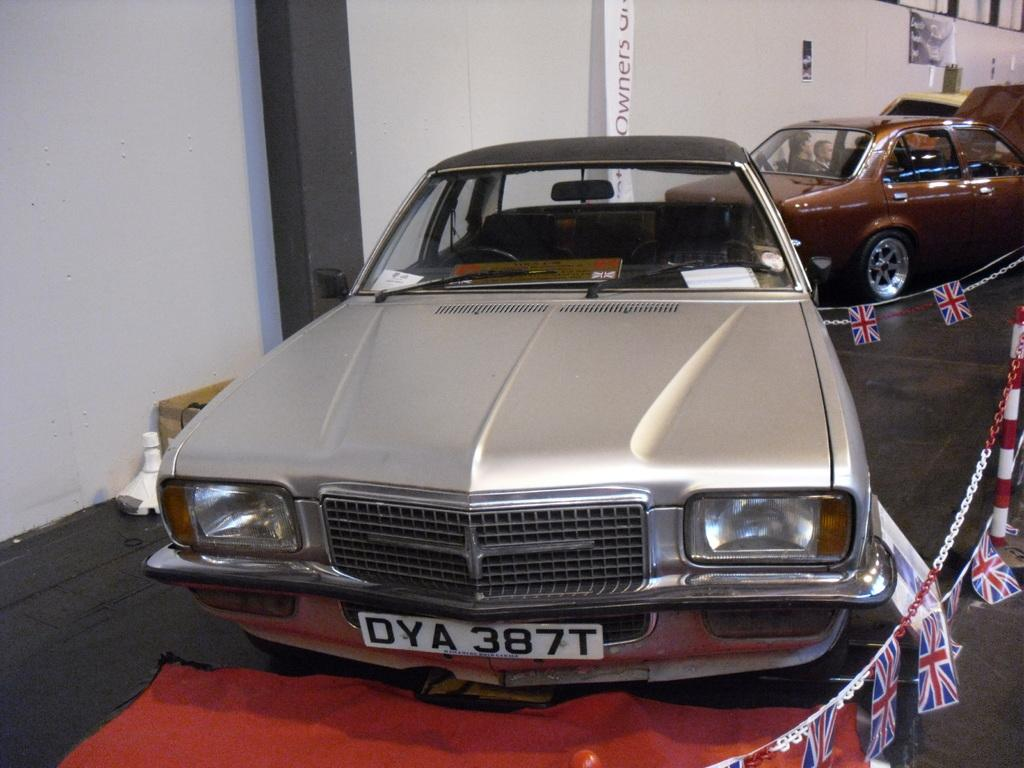What type of vehicles are present in the image? There are cars in the image. Can you describe the appearance of the cars? The cars are of different colors and are of the same model. What is happening with the cars in the background of the image? There are persons sitting in a car in the background of the image. What can be seen in the background of the image besides the car? There is a wall in the background of the image. Where is the zoo located in the image? There is no zoo present in the image. What type of cream is being used to decorate the cars in the image? There is no cream being used to decorate the cars in the image. 